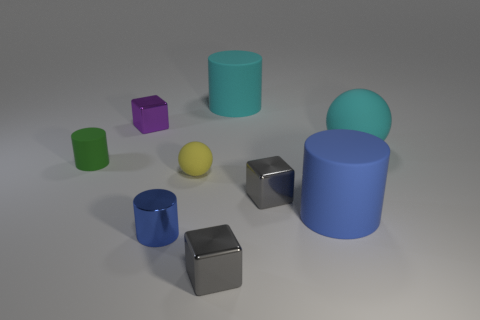There is a cyan object that is the same shape as the small yellow object; what size is it?
Your answer should be very brief. Large. The small metal thing that is behind the tiny blue metallic cylinder and right of the purple thing has what shape?
Give a very brief answer. Cube. What number of other things are there of the same color as the small rubber sphere?
Provide a succinct answer. 0. The green matte thing is what shape?
Make the answer very short. Cylinder. There is a shiny thing that is right of the tiny gray thing in front of the large blue thing; what is its color?
Provide a short and direct response. Gray. Does the big rubber ball have the same color as the large cylinder that is on the left side of the blue rubber cylinder?
Give a very brief answer. Yes. There is a object that is behind the green rubber thing and in front of the purple block; what material is it?
Ensure brevity in your answer.  Rubber. Are there any yellow objects of the same size as the green matte thing?
Give a very brief answer. Yes. What material is the blue thing that is the same size as the cyan matte sphere?
Provide a succinct answer. Rubber. There is a cyan rubber cylinder; what number of large cyan things are in front of it?
Make the answer very short. 1. 